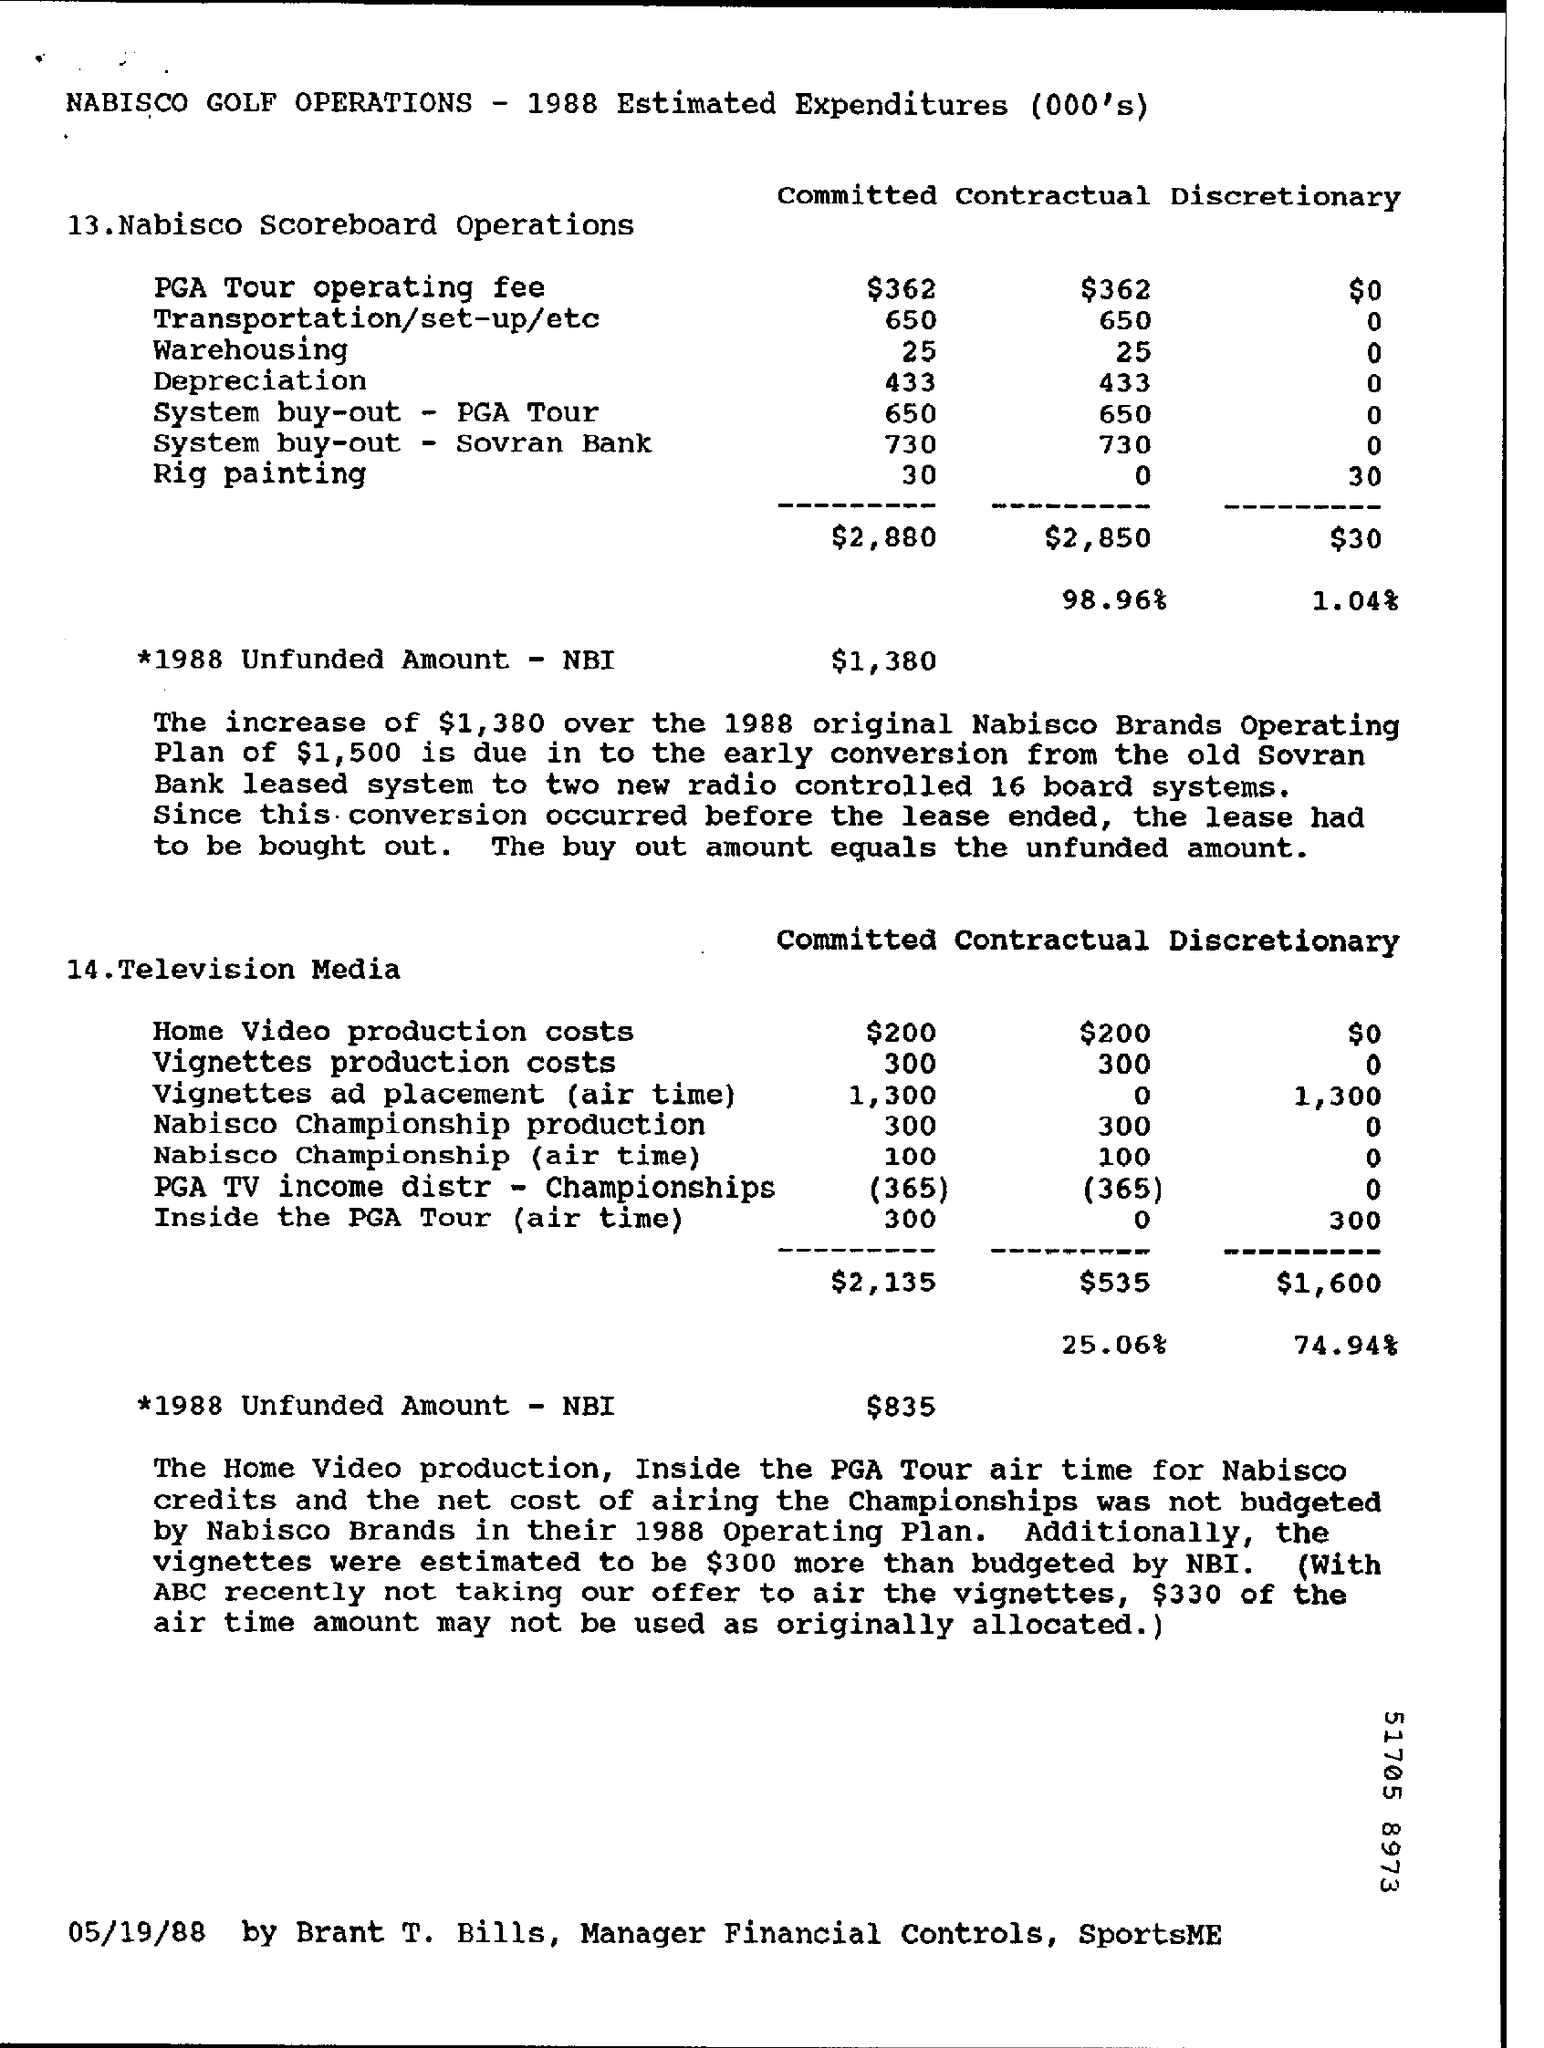What is the estimated committed expenditure of nabisco scoreboard operations in warehousing ?
Ensure brevity in your answer.  25. What is the estimated expenditure of contractual rig painting in nabisco scoreboard operations ?
Offer a very short reply. 0. What is the unfunded amount - nbi in 1988 for nabisco scoreboard operations ?
Offer a terse response. 1,380. What is the estimated expenditure of committed home video production costs in television media  ?
Your answer should be very brief. $ 200. What is the estimated expenditure of contractual vignettes production costs in television media ?
Provide a succinct answer. 300. What is the unfunded amount -nbi in the year 1988 for television media ?
Make the answer very short. $835. 